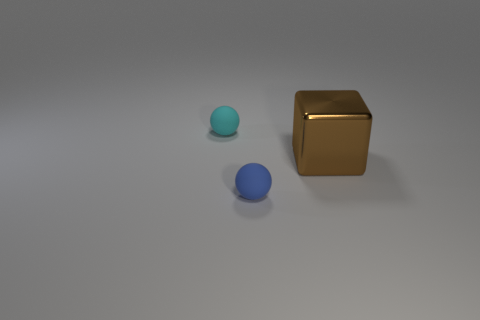Subtract all blue cubes. Subtract all yellow cylinders. How many cubes are left? 1 Add 2 big brown metal objects. How many objects exist? 5 Subtract all balls. How many objects are left? 1 Subtract 0 red balls. How many objects are left? 3 Subtract all brown metal blocks. Subtract all brown cubes. How many objects are left? 1 Add 1 brown shiny objects. How many brown shiny objects are left? 2 Add 3 shiny things. How many shiny things exist? 4 